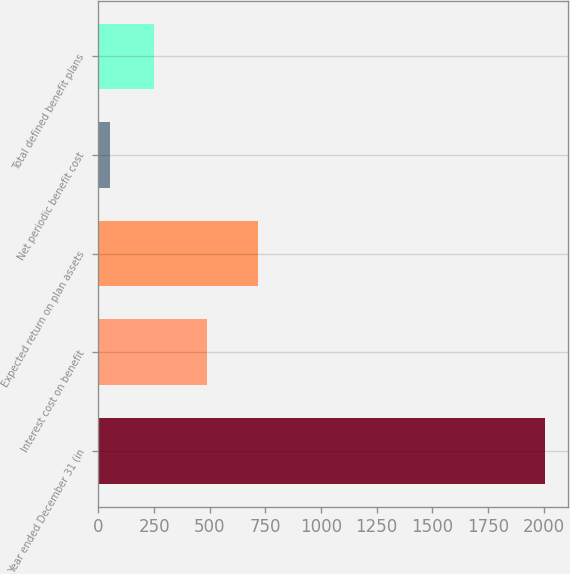Convert chart to OTSL. <chart><loc_0><loc_0><loc_500><loc_500><bar_chart><fcel>Year ended December 31 (in<fcel>Interest cost on benefit<fcel>Expected return on plan assets<fcel>Net periodic benefit cost<fcel>Total defined benefit plans<nl><fcel>2008<fcel>488<fcel>719<fcel>52<fcel>247.6<nl></chart> 